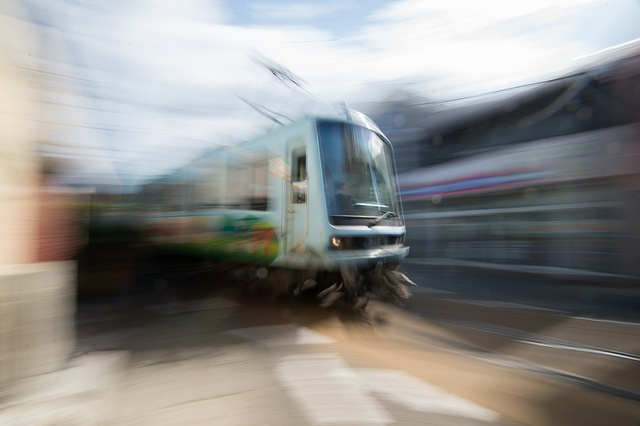Describe the objects in this image and their specific colors. I can see train in lightgray, black, gray, and darkgray tones and train in lightgray, gray, black, and darkblue tones in this image. 